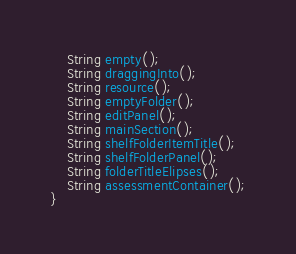<code> <loc_0><loc_0><loc_500><loc_500><_Java_>	String empty();
	String draggingInto();
	String resource();
	String emptyFolder();
	String editPanel();
	String mainSection();
	String shelfFolderItemTitle();
	String shelfFolderPanel();
	String folderTitleElipses();
	String assessmentContainer();
}</code> 